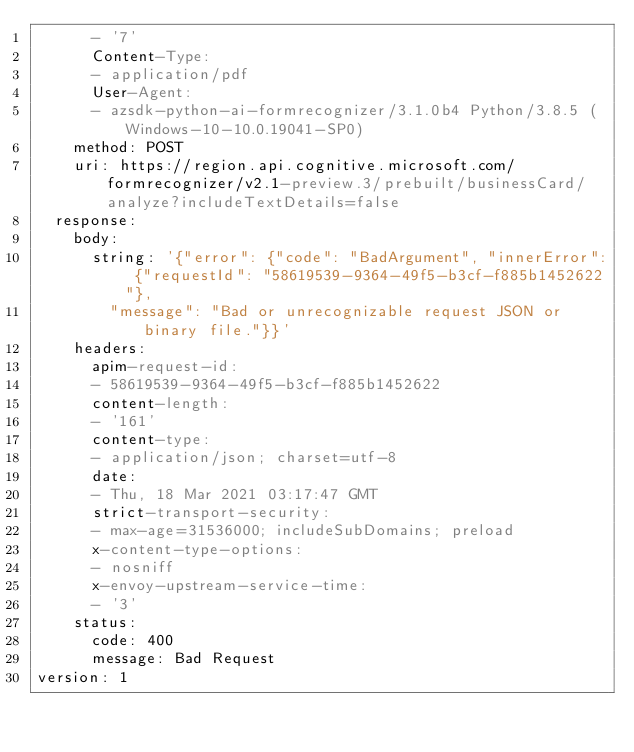Convert code to text. <code><loc_0><loc_0><loc_500><loc_500><_YAML_>      - '7'
      Content-Type:
      - application/pdf
      User-Agent:
      - azsdk-python-ai-formrecognizer/3.1.0b4 Python/3.8.5 (Windows-10-10.0.19041-SP0)
    method: POST
    uri: https://region.api.cognitive.microsoft.com/formrecognizer/v2.1-preview.3/prebuilt/businessCard/analyze?includeTextDetails=false
  response:
    body:
      string: '{"error": {"code": "BadArgument", "innerError": {"requestId": "58619539-9364-49f5-b3cf-f885b1452622"},
        "message": "Bad or unrecognizable request JSON or binary file."}}'
    headers:
      apim-request-id:
      - 58619539-9364-49f5-b3cf-f885b1452622
      content-length:
      - '161'
      content-type:
      - application/json; charset=utf-8
      date:
      - Thu, 18 Mar 2021 03:17:47 GMT
      strict-transport-security:
      - max-age=31536000; includeSubDomains; preload
      x-content-type-options:
      - nosniff
      x-envoy-upstream-service-time:
      - '3'
    status:
      code: 400
      message: Bad Request
version: 1
</code> 